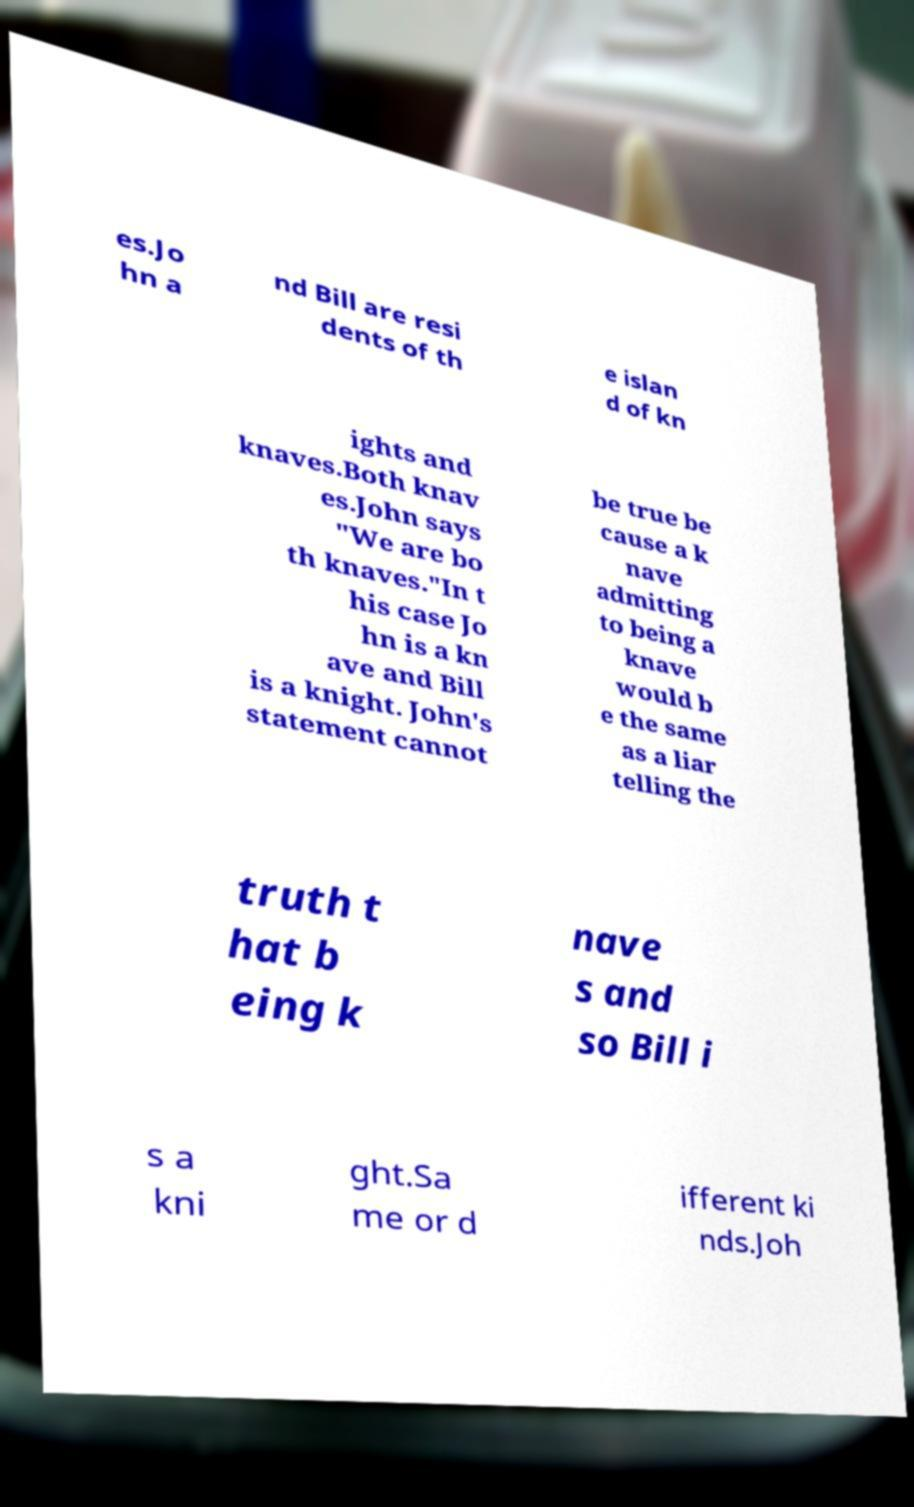There's text embedded in this image that I need extracted. Can you transcribe it verbatim? es.Jo hn a nd Bill are resi dents of th e islan d of kn ights and knaves.Both knav es.John says "We are bo th knaves."In t his case Jo hn is a kn ave and Bill is a knight. John's statement cannot be true be cause a k nave admitting to being a knave would b e the same as a liar telling the truth t hat b eing k nave s and so Bill i s a kni ght.Sa me or d ifferent ki nds.Joh 